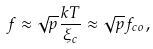Convert formula to latex. <formula><loc_0><loc_0><loc_500><loc_500>f \approx \sqrt { p } \frac { k T } { \xi _ { c } } \approx \sqrt { p } f _ { c o } ,</formula> 